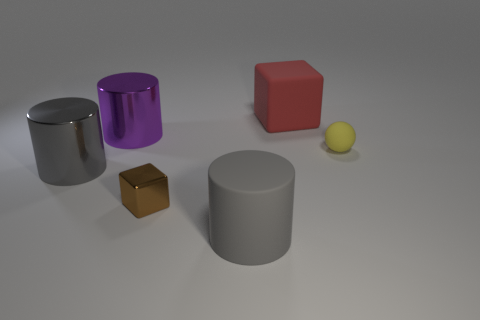Is the shape of the tiny brown object the same as the big red object?
Your answer should be very brief. Yes. How many big metal objects are both right of the gray metallic thing and in front of the purple cylinder?
Your answer should be compact. 0. What number of shiny things are big gray things or yellow things?
Provide a succinct answer. 1. What size is the block left of the rubber object in front of the small yellow object?
Offer a terse response. Small. What is the material of the other cylinder that is the same color as the large matte cylinder?
Your answer should be compact. Metal. Is there a brown metal object behind the gray cylinder on the left side of the metal object that is in front of the gray metal thing?
Your response must be concise. No. Do the big thing that is in front of the brown object and the gray object behind the rubber cylinder have the same material?
Your answer should be very brief. No. What number of objects are rubber cubes or spheres on the right side of the gray rubber cylinder?
Give a very brief answer. 2. What number of other objects are the same shape as the purple object?
Give a very brief answer. 2. What is the material of the red cube that is the same size as the purple cylinder?
Your response must be concise. Rubber. 